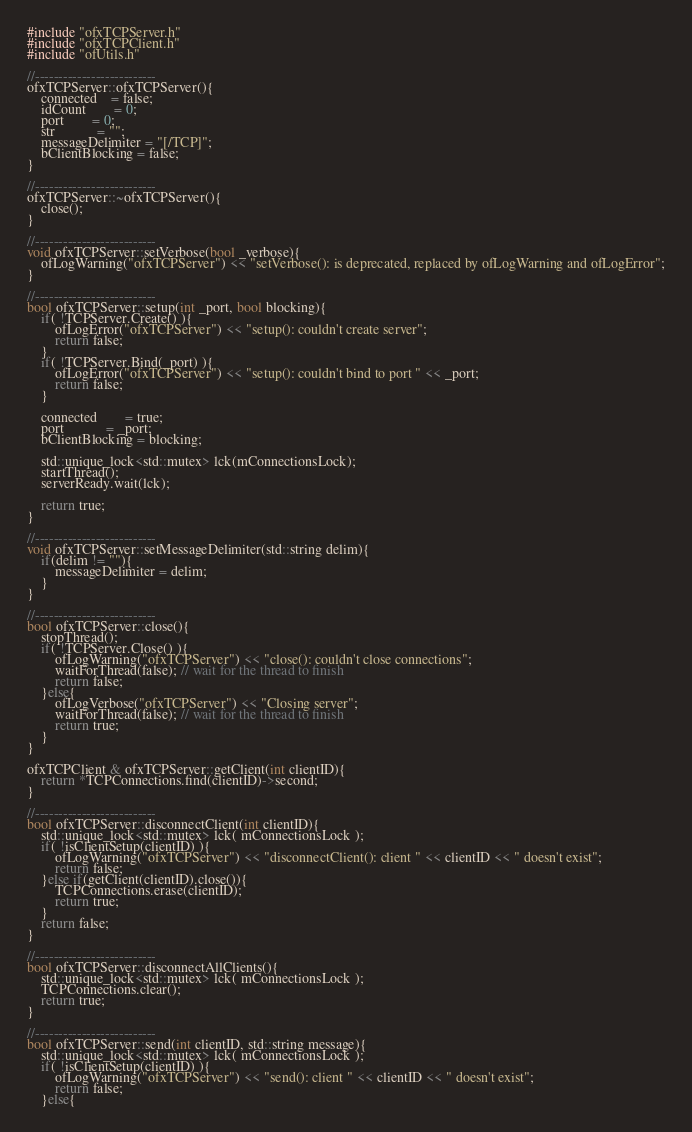Convert code to text. <code><loc_0><loc_0><loc_500><loc_500><_C++_>#include "ofxTCPServer.h"
#include "ofxTCPClient.h"
#include "ofUtils.h"

//--------------------------
ofxTCPServer::ofxTCPServer(){
	connected	= false;
	idCount		= 0;
	port		= 0;
	str			= "";
	messageDelimiter = "[/TCP]";
	bClientBlocking = false;
}

//--------------------------
ofxTCPServer::~ofxTCPServer(){
	close();
}

//--------------------------
void ofxTCPServer::setVerbose(bool _verbose){
	ofLogWarning("ofxTCPServer") << "setVerbose(): is deprecated, replaced by ofLogWarning and ofLogError";
}

//--------------------------
bool ofxTCPServer::setup(int _port, bool blocking){
	if( !TCPServer.Create() ){
		ofLogError("ofxTCPServer") << "setup(): couldn't create server";
		return false;
	}
	if( !TCPServer.Bind(_port) ){
		ofLogError("ofxTCPServer") << "setup(): couldn't bind to port " << _port;
		return false;
	}

	connected		= true;
	port			= _port;
	bClientBlocking = blocking;

	std::unique_lock<std::mutex> lck(mConnectionsLock);
	startThread();
    serverReady.wait(lck);

	return true;
}

//--------------------------
void ofxTCPServer::setMessageDelimiter(std::string delim){
	if(delim != ""){
		messageDelimiter = delim;
	}
}

//--------------------------
bool ofxTCPServer::close(){
    stopThread();
	if( !TCPServer.Close() ){
		ofLogWarning("ofxTCPServer") << "close(): couldn't close connections";
		waitForThread(false); // wait for the thread to finish
		return false;
    }else{
        ofLogVerbose("ofxTCPServer") << "Closing server";
		waitForThread(false); // wait for the thread to finish
		return true;
	}
}

ofxTCPClient & ofxTCPServer::getClient(int clientID){
	return *TCPConnections.find(clientID)->second;
}

//--------------------------
bool ofxTCPServer::disconnectClient(int clientID){
	std::unique_lock<std::mutex> lck( mConnectionsLock );
	if( !isClientSetup(clientID) ){
		ofLogWarning("ofxTCPServer") << "disconnectClient(): client " << clientID << " doesn't exist";
		return false;
	}else if(getClient(clientID).close()){
		TCPConnections.erase(clientID);
		return true;
	}
	return false;
}

//--------------------------
bool ofxTCPServer::disconnectAllClients(){
	std::unique_lock<std::mutex> lck( mConnectionsLock );
    TCPConnections.clear();
    return true;
}

//--------------------------
bool ofxTCPServer::send(int clientID, std::string message){
	std::unique_lock<std::mutex> lck( mConnectionsLock );
	if( !isClientSetup(clientID) ){
		ofLogWarning("ofxTCPServer") << "send(): client " << clientID << " doesn't exist";
		return false;
	}else{</code> 